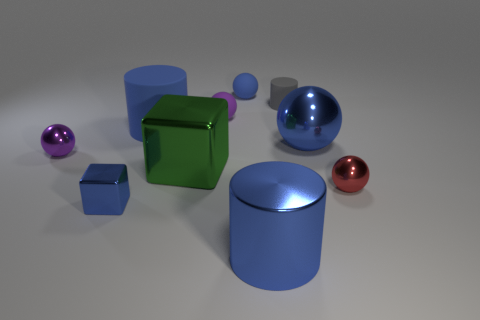What color is the matte cylinder that is the same size as the blue block? The matte cylinder that matches the size of the blue block is gray, exhibiting a neutral tone that contrasts with the varying hues and reflective surfaces of the other objects in the image. 